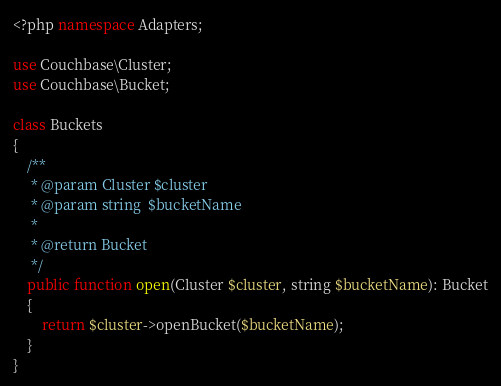<code> <loc_0><loc_0><loc_500><loc_500><_PHP_><?php namespace Adapters;

use Couchbase\Cluster;
use Couchbase\Bucket;

class Buckets
{
	/**
	 * @param Cluster $cluster
	 * @param string  $bucketName
	 *
	 * @return Bucket
	 */
	public function open(Cluster $cluster, string $bucketName): Bucket
	{
		return $cluster->openBucket($bucketName);
	}
}
</code> 